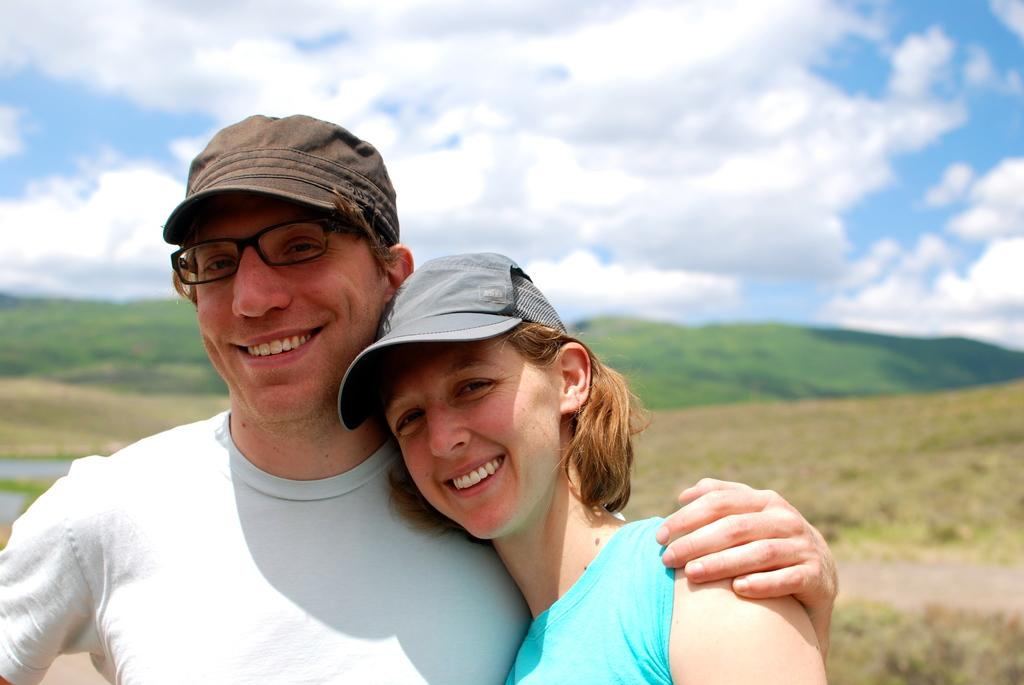Who are the people in the image? There is a lady and a guy in the image. What are they wearing on their heads? Both the lady and the guy are wearing caps. What can be seen in the background of the image? There are mountains and trees visible in the image. How would you describe the weather based on the image? The sky is cloudy in the image, suggesting a potentially overcast or cloudy day. What type of blade can be seen cutting through the wire in the image? There is no blade or wire present in the image; it features a lady, a guy, mountains, trees, and a cloudy sky. 